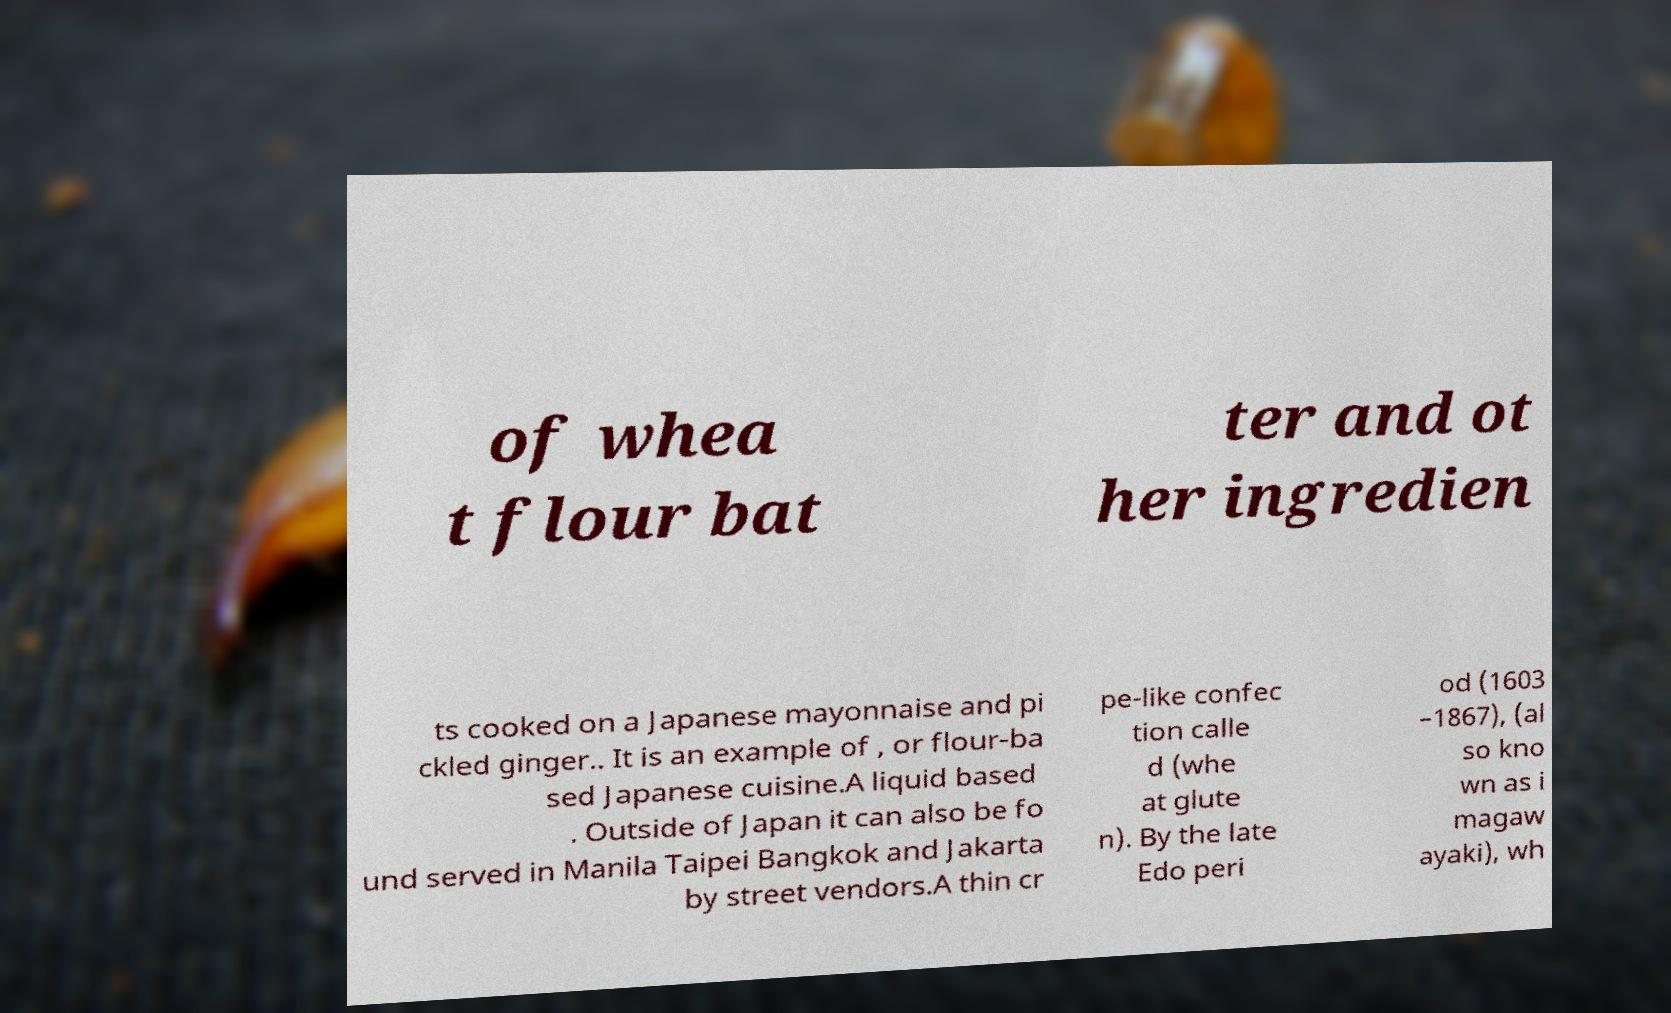Could you assist in decoding the text presented in this image and type it out clearly? of whea t flour bat ter and ot her ingredien ts cooked on a Japanese mayonnaise and pi ckled ginger.. It is an example of , or flour-ba sed Japanese cuisine.A liquid based . Outside of Japan it can also be fo und served in Manila Taipei Bangkok and Jakarta by street vendors.A thin cr pe-like confec tion calle d (whe at glute n). By the late Edo peri od (1603 –1867), (al so kno wn as i magaw ayaki), wh 